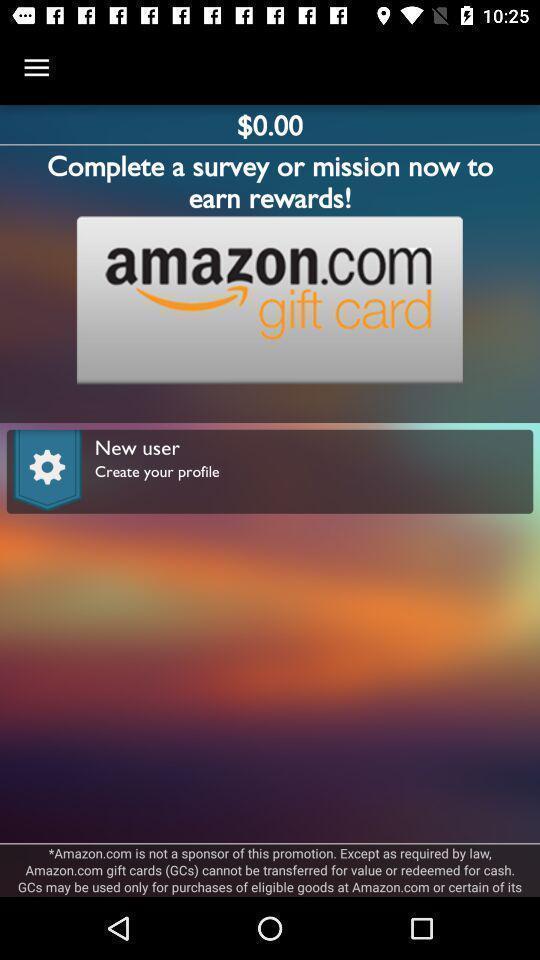What details can you identify in this image? Screen displaying contents in rewards page. 